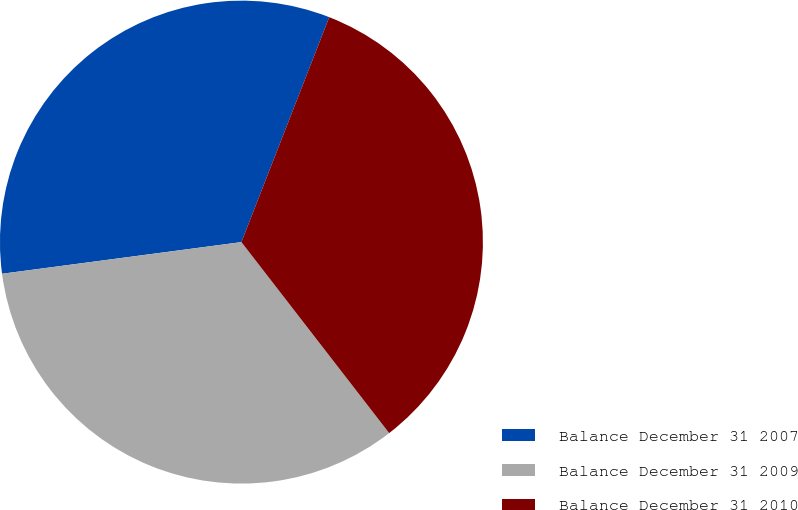<chart> <loc_0><loc_0><loc_500><loc_500><pie_chart><fcel>Balance December 31 2007<fcel>Balance December 31 2009<fcel>Balance December 31 2010<nl><fcel>33.02%<fcel>33.39%<fcel>33.6%<nl></chart> 